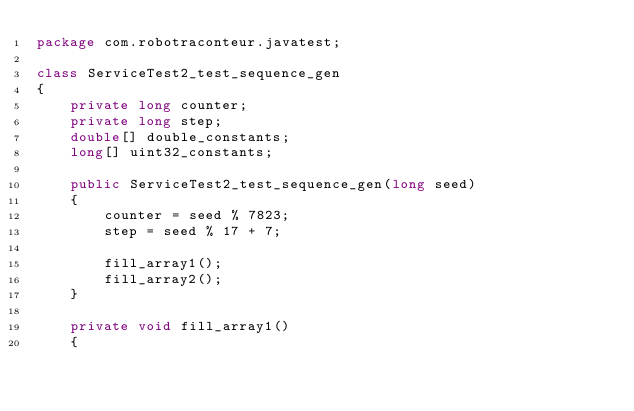Convert code to text. <code><loc_0><loc_0><loc_500><loc_500><_Java_>package com.robotraconteur.javatest;

class ServiceTest2_test_sequence_gen
{
	private long counter;
	private long step;
	double[] double_constants;
	long[] uint32_constants;

	public ServiceTest2_test_sequence_gen(long seed)
	{
		counter = seed % 7823;
		step = seed % 17 + 7;
		
		fill_array1();
		fill_array2();
	}

	private void fill_array1()
	{</code> 